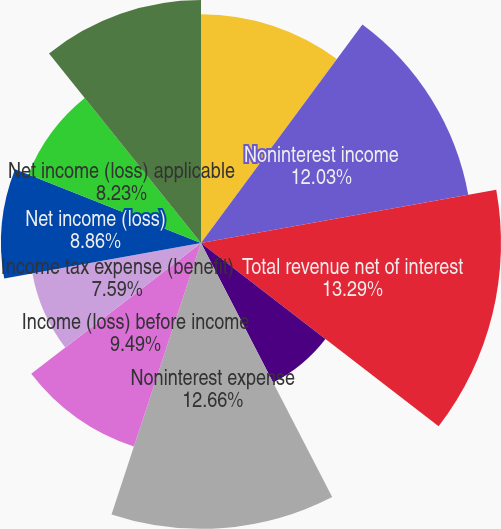Convert chart to OTSL. <chart><loc_0><loc_0><loc_500><loc_500><pie_chart><fcel>Net interest income<fcel>Noninterest income<fcel>Total revenue net of interest<fcel>Provision for credit losses<fcel>Noninterest expense<fcel>Income (loss) before income<fcel>Income tax expense (benefit)<fcel>Net income (loss)<fcel>Net income (loss) applicable<fcel>Average common shares issued<nl><fcel>10.13%<fcel>12.03%<fcel>13.29%<fcel>6.96%<fcel>12.66%<fcel>9.49%<fcel>7.59%<fcel>8.86%<fcel>8.23%<fcel>10.76%<nl></chart> 